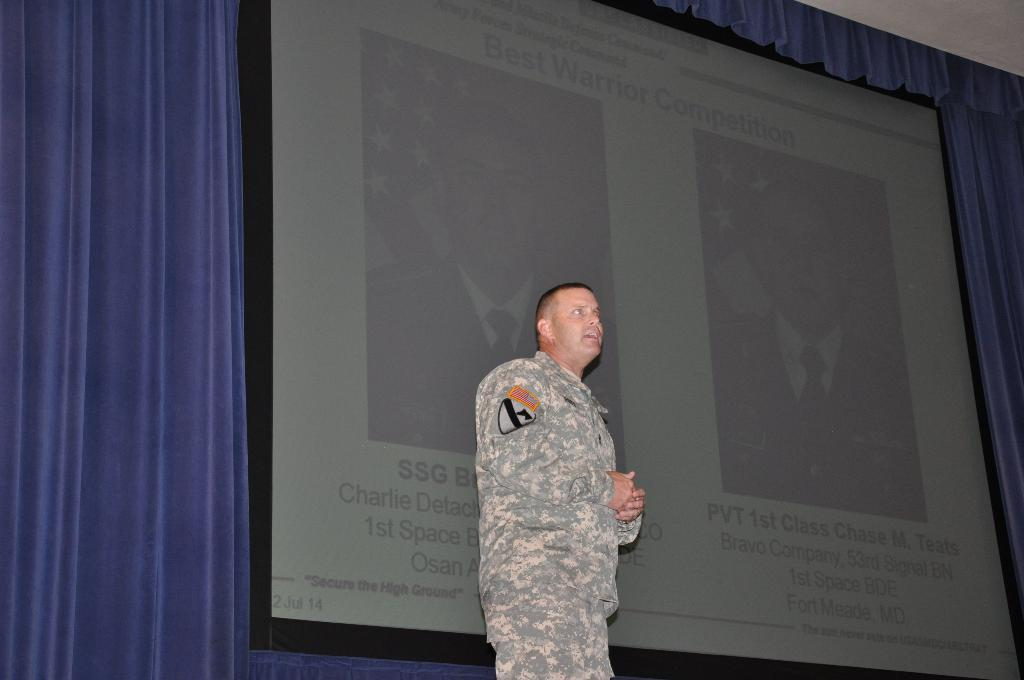What is the main subject of the image? There is a person standing in the center of the image. What can be seen in the background of the image? There is a curtain, a screen, and a roof in the background of the image. What is written on the screen in the image? There is something written on the screen in the image. How many stars can be seen on the person's shirt in the image? There is no mention of stars or a shirt in the provided facts, so we cannot determine the number of stars on the person's shirt in the image. What type of clam is depicted on the curtain in the image? There is no mention of a clam or any sea creatures on the curtain in the provided facts, so we cannot determine the type of clam on the curtain in the image. 